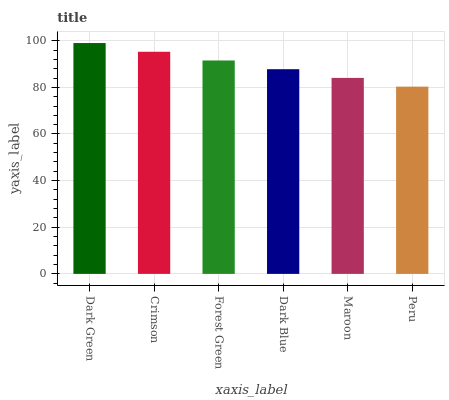Is Peru the minimum?
Answer yes or no. Yes. Is Dark Green the maximum?
Answer yes or no. Yes. Is Crimson the minimum?
Answer yes or no. No. Is Crimson the maximum?
Answer yes or no. No. Is Dark Green greater than Crimson?
Answer yes or no. Yes. Is Crimson less than Dark Green?
Answer yes or no. Yes. Is Crimson greater than Dark Green?
Answer yes or no. No. Is Dark Green less than Crimson?
Answer yes or no. No. Is Forest Green the high median?
Answer yes or no. Yes. Is Dark Blue the low median?
Answer yes or no. Yes. Is Dark Green the high median?
Answer yes or no. No. Is Peru the low median?
Answer yes or no. No. 